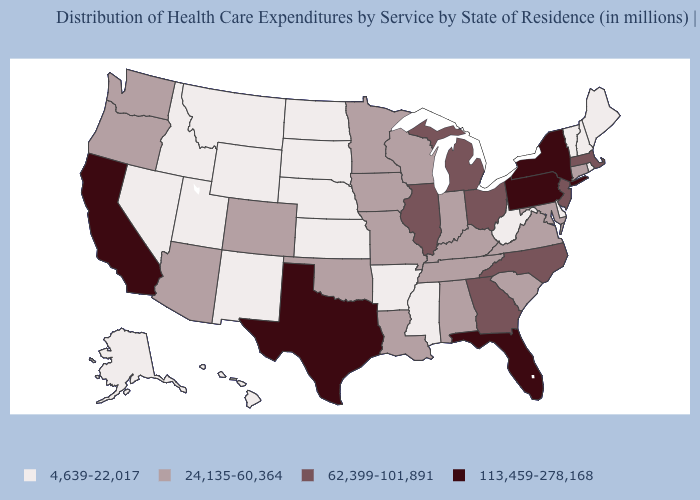Name the states that have a value in the range 62,399-101,891?
Answer briefly. Georgia, Illinois, Massachusetts, Michigan, New Jersey, North Carolina, Ohio. Does Montana have the lowest value in the West?
Give a very brief answer. Yes. What is the value of New Jersey?
Concise answer only. 62,399-101,891. What is the value of Delaware?
Keep it brief. 4,639-22,017. What is the value of Ohio?
Be succinct. 62,399-101,891. How many symbols are there in the legend?
Answer briefly. 4. How many symbols are there in the legend?
Answer briefly. 4. Does Washington have the lowest value in the West?
Be succinct. No. Name the states that have a value in the range 4,639-22,017?
Short answer required. Alaska, Arkansas, Delaware, Hawaii, Idaho, Kansas, Maine, Mississippi, Montana, Nebraska, Nevada, New Hampshire, New Mexico, North Dakota, Rhode Island, South Dakota, Utah, Vermont, West Virginia, Wyoming. What is the value of Iowa?
Keep it brief. 24,135-60,364. Does Alaska have the lowest value in the West?
Give a very brief answer. Yes. Among the states that border Maryland , which have the lowest value?
Keep it brief. Delaware, West Virginia. What is the value of Mississippi?
Answer briefly. 4,639-22,017. What is the value of Kentucky?
Concise answer only. 24,135-60,364. Name the states that have a value in the range 4,639-22,017?
Keep it brief. Alaska, Arkansas, Delaware, Hawaii, Idaho, Kansas, Maine, Mississippi, Montana, Nebraska, Nevada, New Hampshire, New Mexico, North Dakota, Rhode Island, South Dakota, Utah, Vermont, West Virginia, Wyoming. 